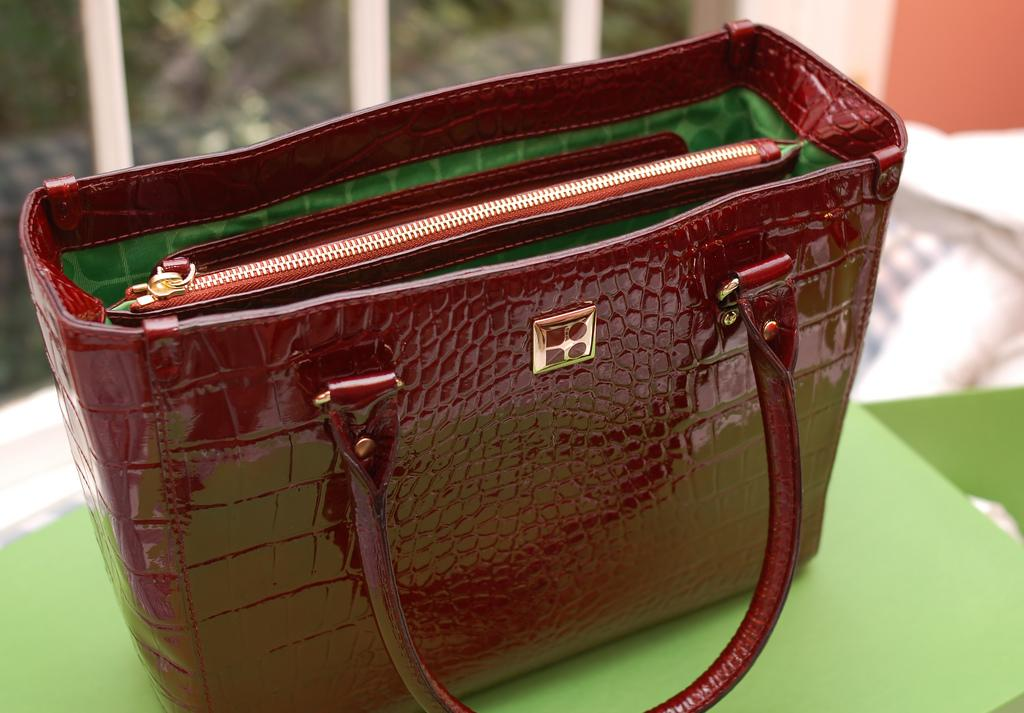What type of accessory is visible in the image? There is a handbag in the image. What type of kettle is visible in the image? There is no kettle present in the image; it only features a handbag. What type of print can be seen on the handbag in the image? The fact provided does not mention any specific print on the handbag, so it cannot be determined from the image. 